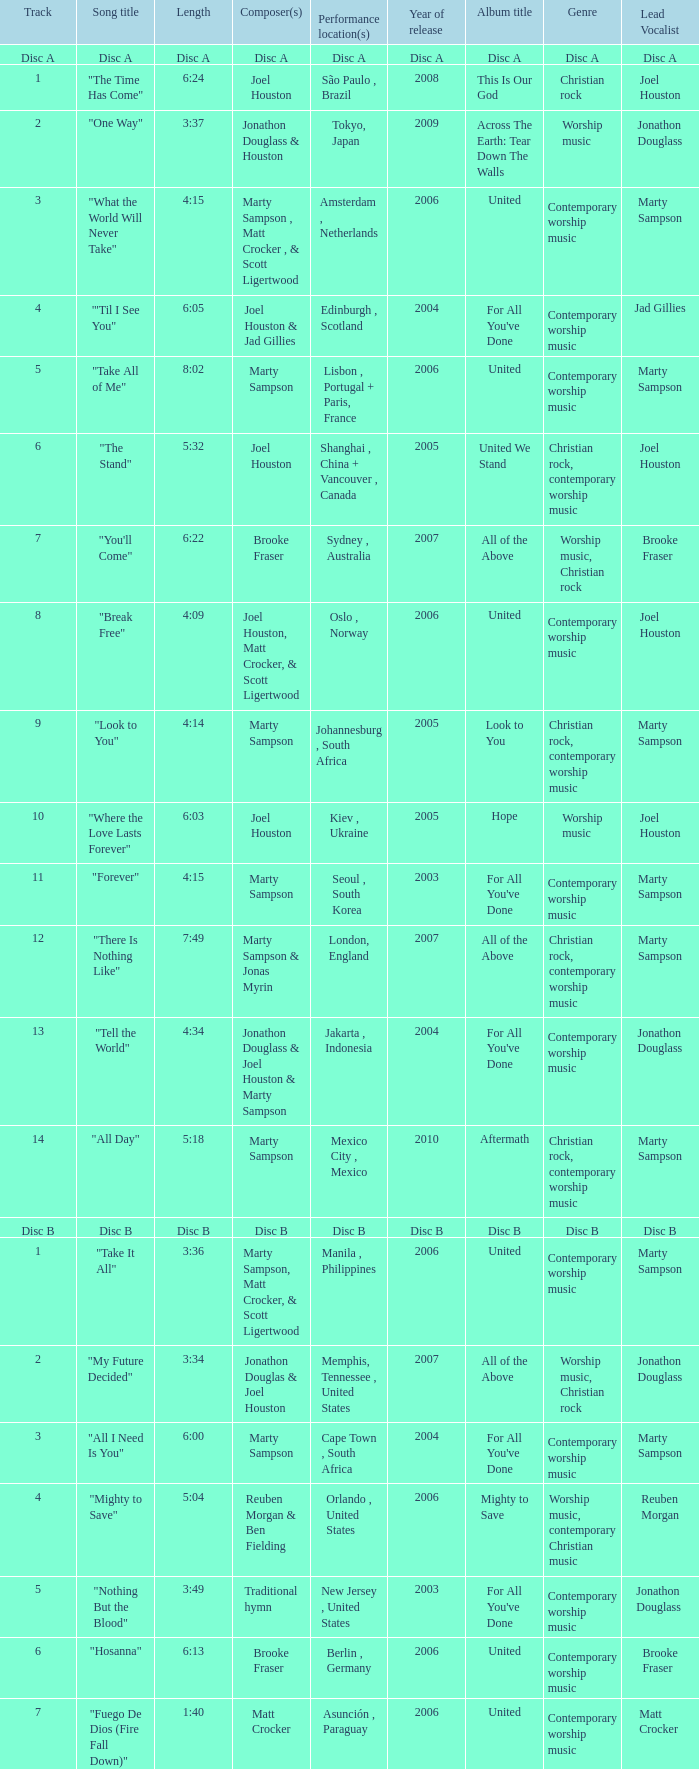Who is the composer of the song with a length of 6:24? Joel Houston. 